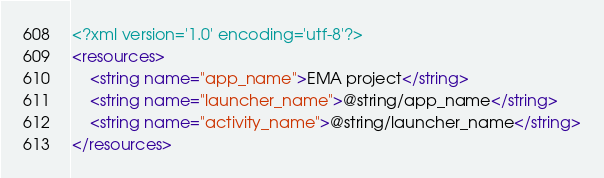<code> <loc_0><loc_0><loc_500><loc_500><_XML_><?xml version='1.0' encoding='utf-8'?>
<resources>
    <string name="app_name">EMA project</string>
    <string name="launcher_name">@string/app_name</string>
    <string name="activity_name">@string/launcher_name</string>
</resources>
</code> 